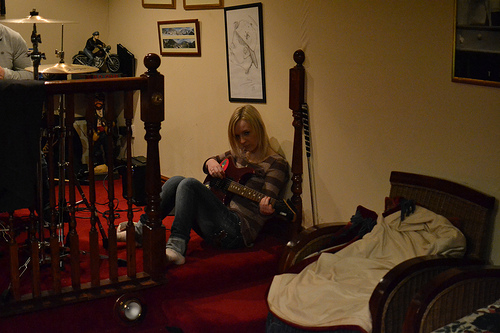<image>
Can you confirm if the guitar is on the woman? Yes. Looking at the image, I can see the guitar is positioned on top of the woman, with the woman providing support. Where is the drawing in relation to the woman? Is it above the woman? Yes. The drawing is positioned above the woman in the vertical space, higher up in the scene. 